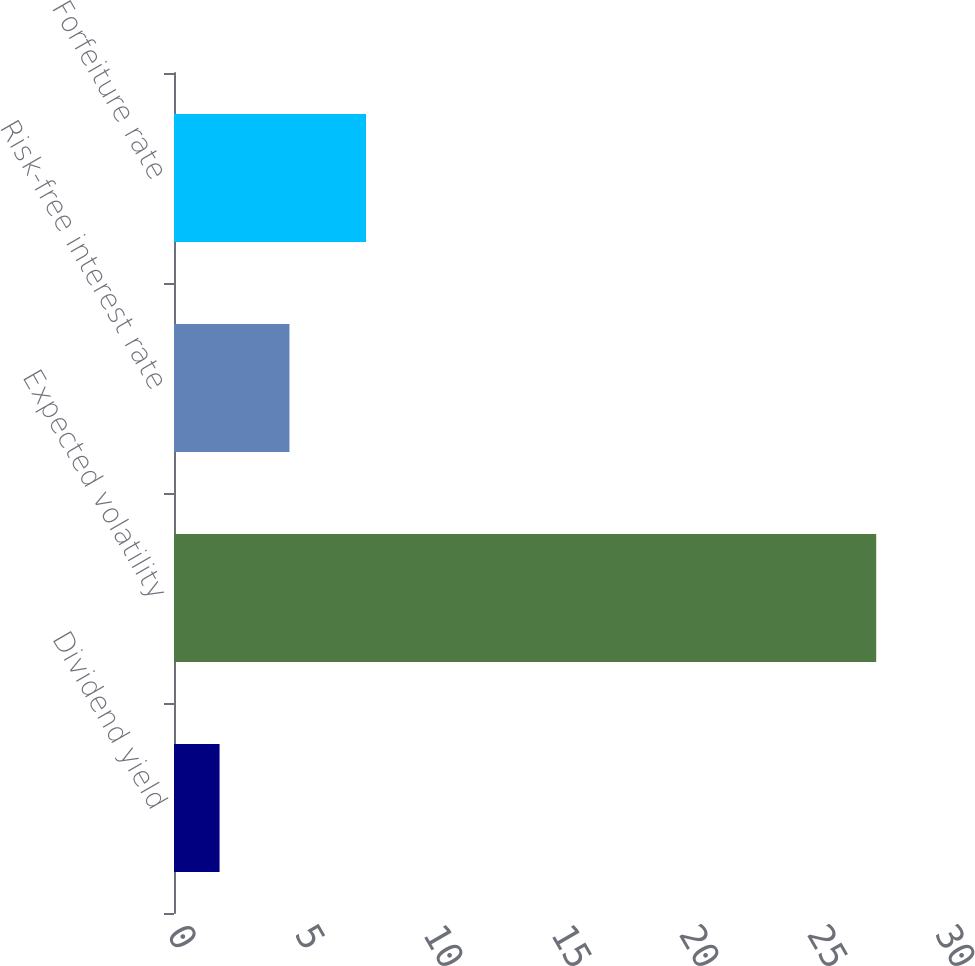<chart> <loc_0><loc_0><loc_500><loc_500><bar_chart><fcel>Dividend yield<fcel>Expected volatility<fcel>Risk-free interest rate<fcel>Forfeiture rate<nl><fcel>1.78<fcel>27.43<fcel>4.51<fcel>7.5<nl></chart> 